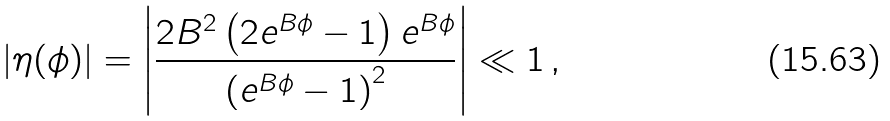Convert formula to latex. <formula><loc_0><loc_0><loc_500><loc_500>\left | \eta ( \phi ) \right | = \left | \frac { 2 B ^ { 2 } \left ( 2 e ^ { B \phi } - 1 \right ) e ^ { B \phi } } { \left ( e ^ { B \phi } - 1 \right ) ^ { 2 } } \right | \ll 1 \, ,</formula> 